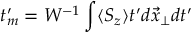<formula> <loc_0><loc_0><loc_500><loc_500>t _ { m } ^ { \prime } = W ^ { - 1 } \int \langle S _ { z } \rangle t ^ { \prime } d \vec { x } _ { \perp } d t ^ { \prime }</formula> 